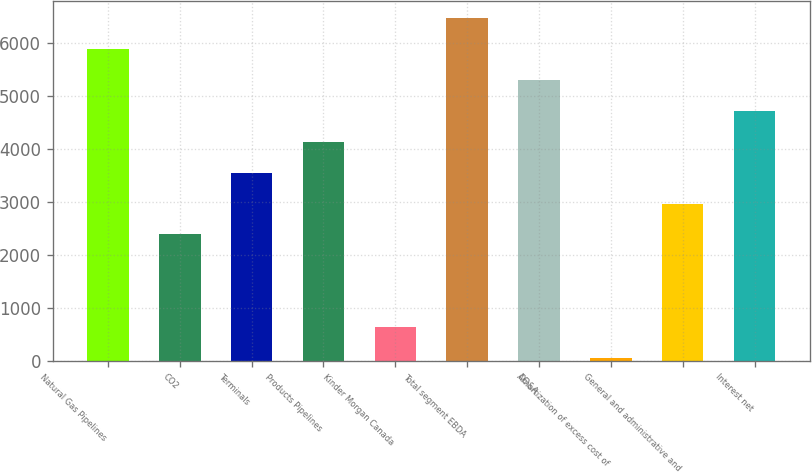Convert chart to OTSL. <chart><loc_0><loc_0><loc_500><loc_500><bar_chart><fcel>Natural Gas Pipelines<fcel>CO2<fcel>Terminals<fcel>Products Pipelines<fcel>Kinder Morgan Canada<fcel>Total segment EBDA<fcel>DD&A<fcel>Amortization of excess cost of<fcel>General and administrative and<fcel>Interest net<nl><fcel>5891<fcel>2387<fcel>3555<fcel>4139<fcel>635<fcel>6475<fcel>5307<fcel>51<fcel>2971<fcel>4723<nl></chart> 